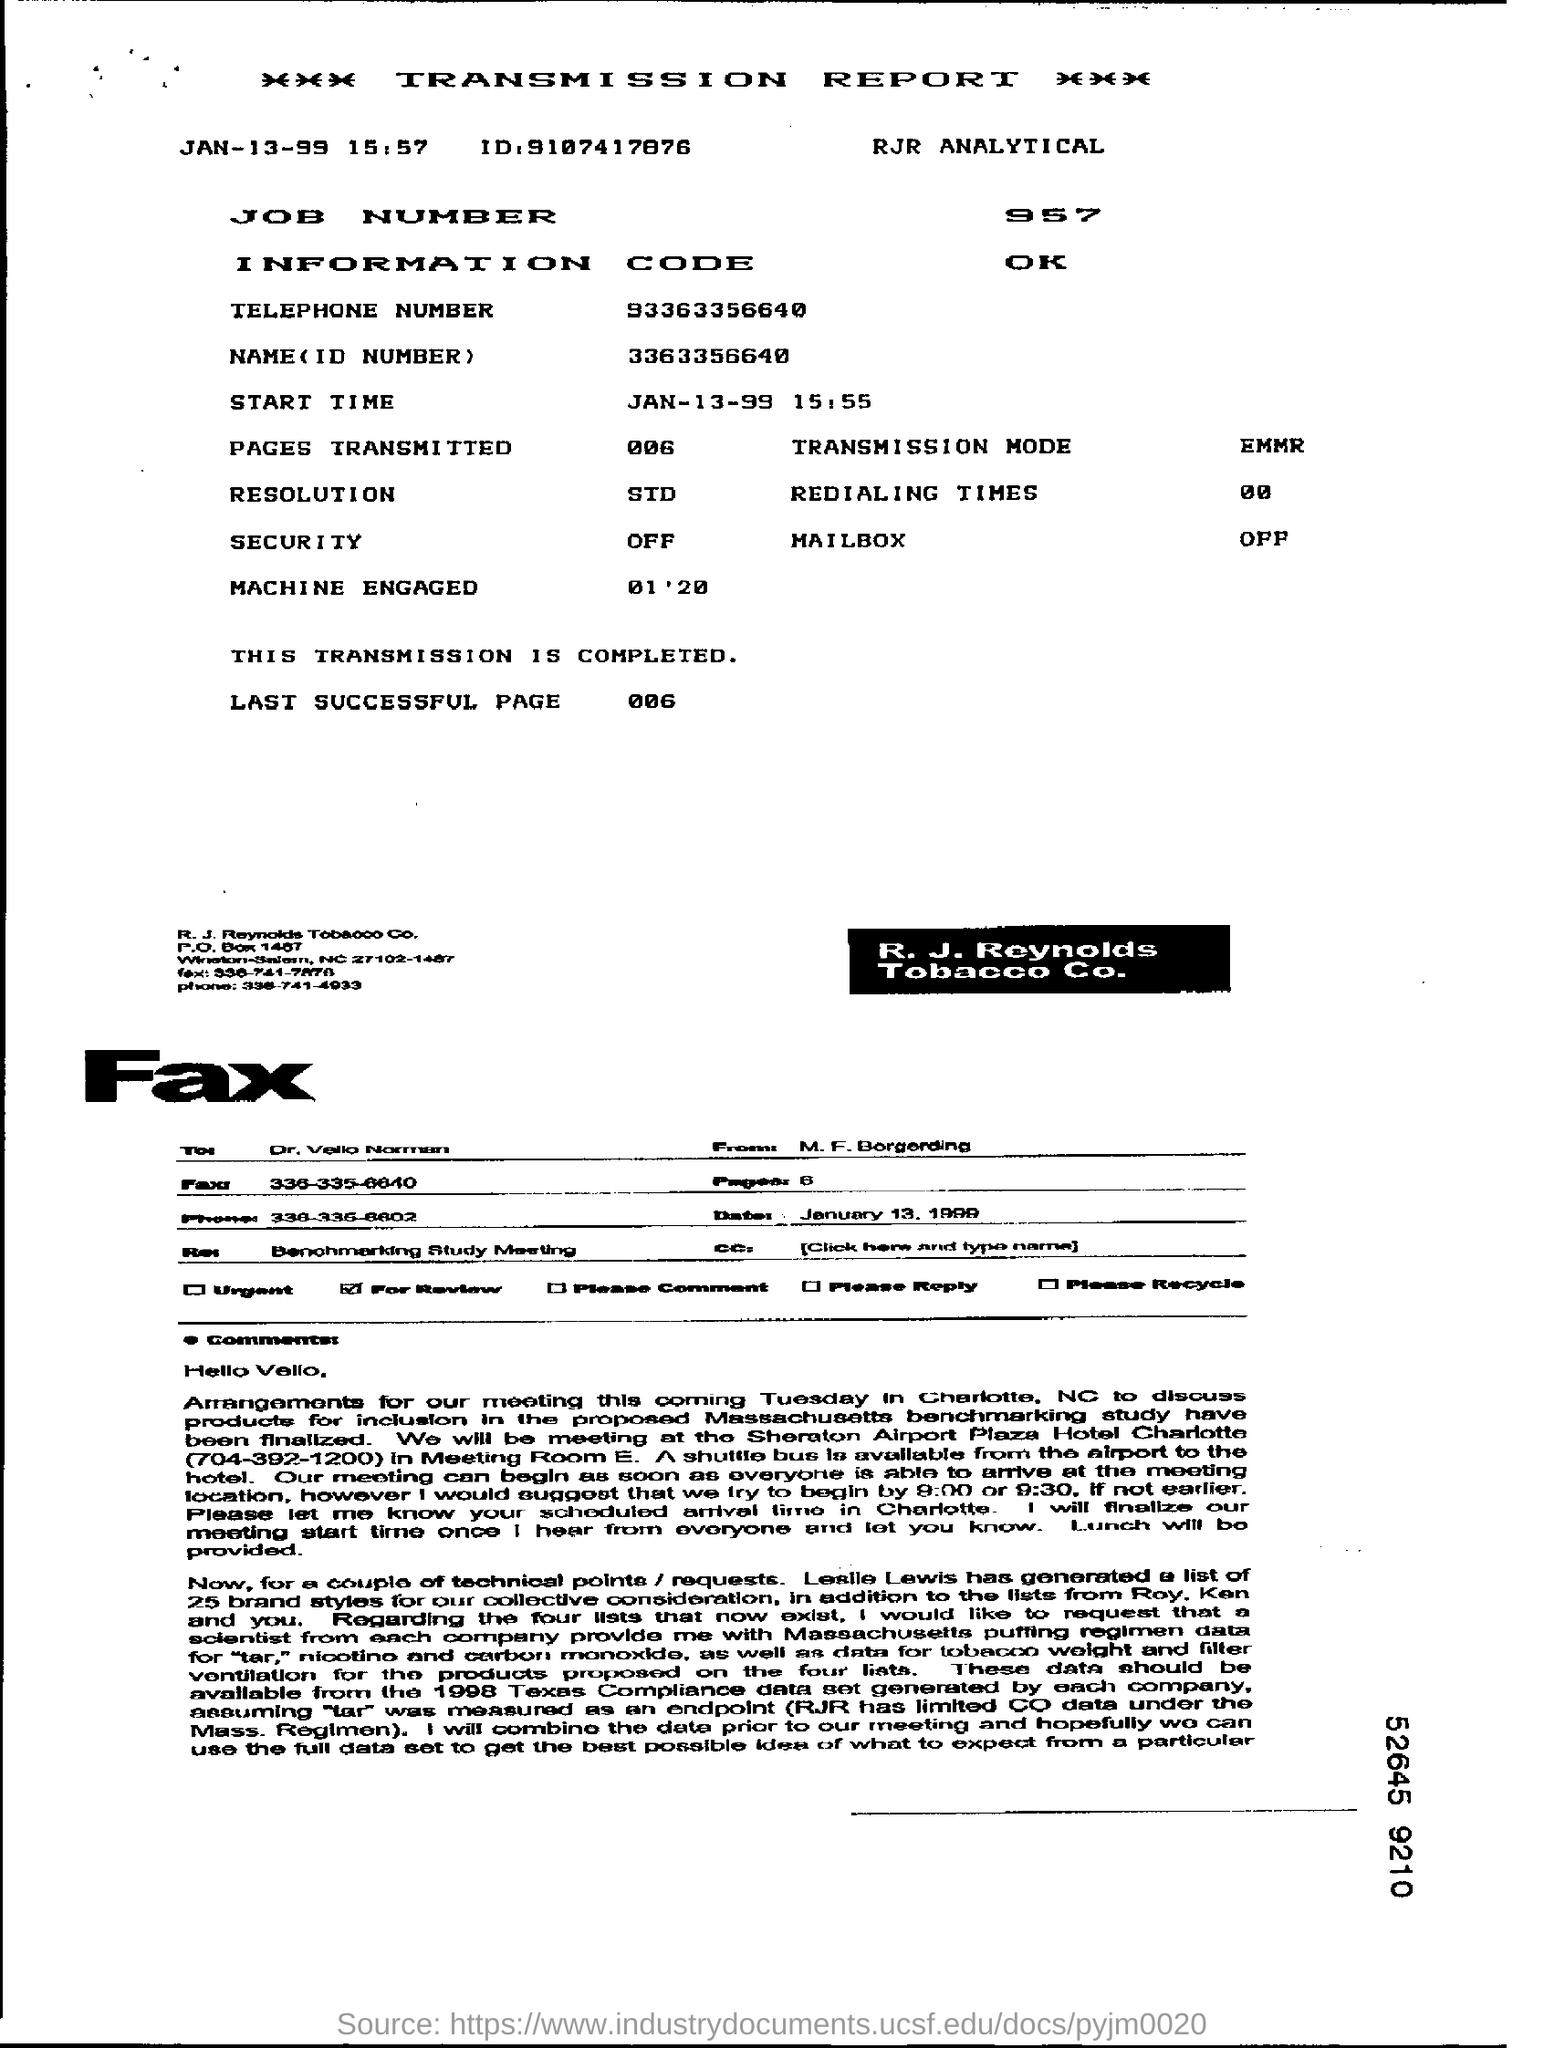What is the ID given?
Ensure brevity in your answer.  9107417876. What is the job number?
Offer a very short reply. 957. What is the telephone number given?
Ensure brevity in your answer.  93363356640. What is the name (ID number)?
Give a very brief answer. 3363356640. What is the transmission mode?
Make the answer very short. Emmr. What is the resolution?
Your answer should be very brief. Std. 